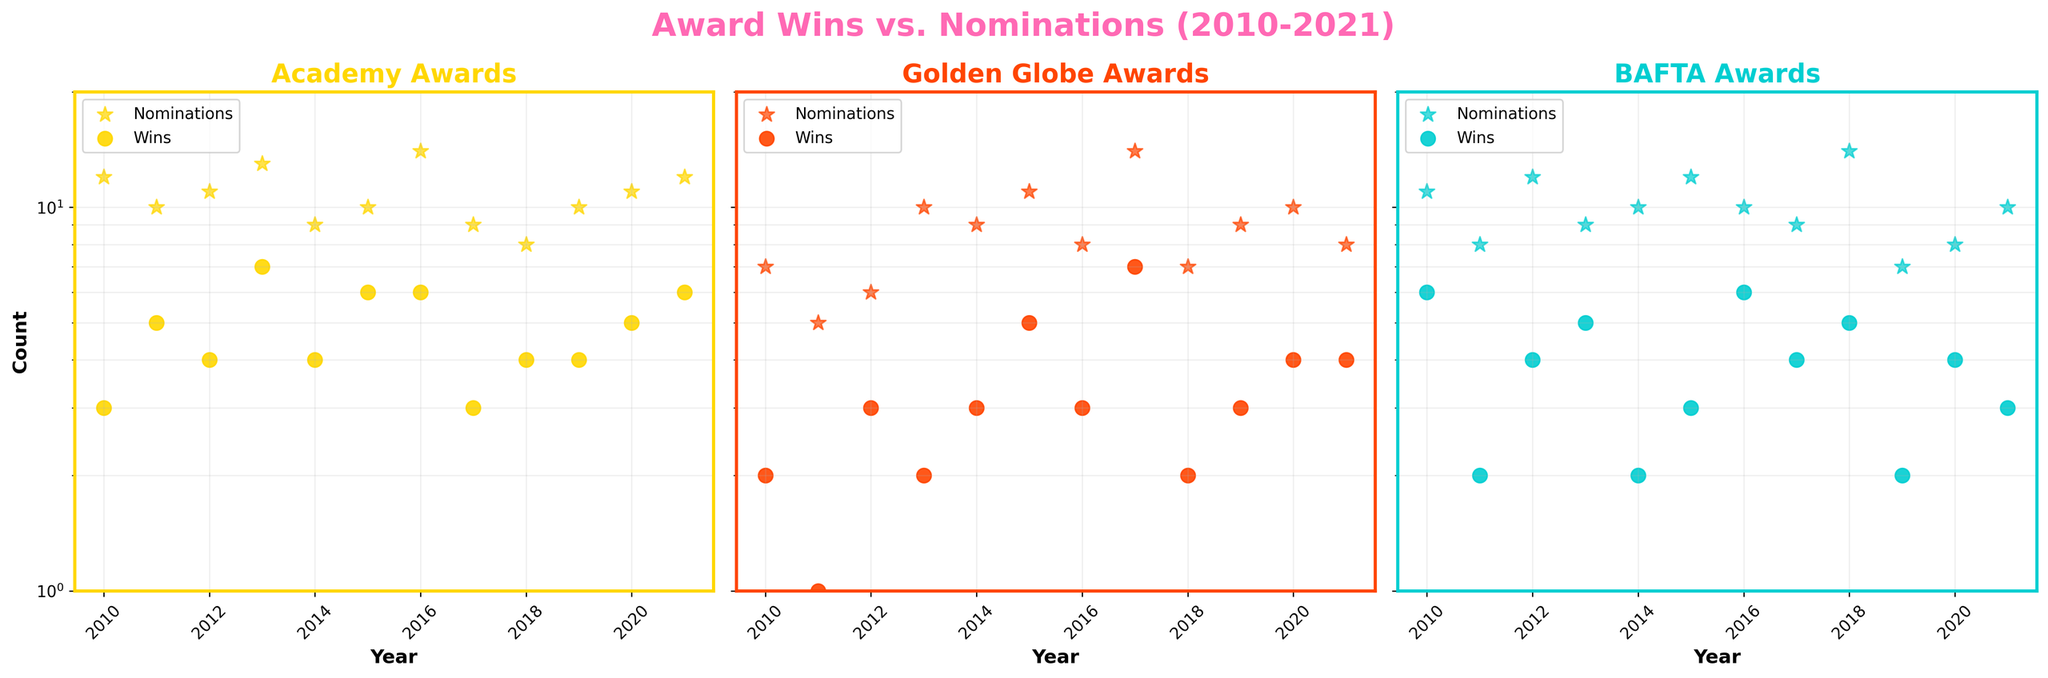What's the title of the figure? The title is prominently shown at the top of the figure and is meant to summarize what the figure represents. In this case, the title is "Award Wins vs. Nominations (2010-2021)".
Answer: Award Wins vs. Nominations (2010-2021) What axis is shared among all subplots? By looking at how the subplots are arranged, it's clear that the y-axis is shared among all of them.
Answer: y-axis Which award has the maximum number of nominations in a single year? Look at each subplot and find the highest data point for "Nominations." For the Academy Awards in 2016, there are 14 nominations, and the same number is also seen in 2017 for the Golden Globe Awards. Comparing all such maximums, 14 is the highest.
Answer: Golden Globe Awards in 2017 (14 nominations) What pattern do you observe in the relationship between wins and nominations for the Academy Awards over the years? Observe the pattern in the subplot for the Academy Awards. Generally, when nominations are high, wins also tend to be higher, although this is not always linear. For instance, 2016 has 14 nominations with 6 wins, while 2015 has 10 nominations with 6 wins.
Answer: Wins often increase with nominations How did the BAFTA Awards perform in terms of wins in 2018 compared to 2019? Compare the data points for wins in those specific years in the BAFTA Awards subplot. In 2018, there were 5 wins, and in 2019, there were 2 wins.
Answer: 5 wins in 2018, 2 wins in 2019 Which award show had the most wins in 2021, and how many were there? Check each subplot for the year 2021 and compare the number of wins. Academy Awards and Golden Globe Awards each had 6 wins, while BAFTA Awards had 3. Therefore, the Academy Awards and Golden Globe Awards tied for most wins with 6 each.
Answer: Academy Awards and Golden Globe Awards (6 wins each) In which year did the Golden Globe Awards record the lowest number of nominations, and how many were there? Look at the Golden Globe Awards subplot and find the lowest data point for nominations. It was in 2011 with 5 nominations.
Answer: 2011 (5 nominations) How many total nominations and wins were there for the BAFTA Awards in 2013? Identify the data points for nominations and wins in 2013 for the BAFTA Awards subplot. There are 9 nominations and 5 wins.
Answer: 9 nominations, 5 wins Compare the consistency of wins between Academy Awards and BAFTA Awards from 2010 to 2021. Observe the trends of wins over the years for both subplots. The Academy Awards show some fluctuations but have a centered average around 4-6 wins, whereas BAFTA Awards have more variable performance, with wins ranging from 2 to 6.
Answer: Academy Awards are more consistent; BAFTA Awards are more variable What is the range of nominations for the Golden Globe Awards from 2010 to 2021? To find the range, identify the minimum and maximum number of nominations within the Golden Globe Awards subplot. The minimum nominations are 5 (in 2011), and the maximum nominations are 14 (in 2017). Therefore, the range is 14 - 5 = 9.
Answer: 9 